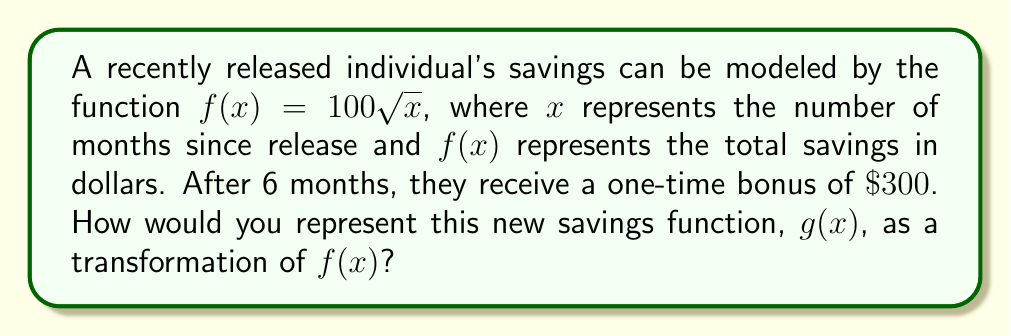What is the answer to this math problem? To solve this problem, we need to consider how the original function $f(x)$ is affected by the bonus:

1. The original function $f(x) = 100\sqrt{x}$ represents the savings growth over time.

2. The $300 bonus is received after 6 months, which means:
   - For $x < 6$, the function remains unchanged.
   - For $x \geq 6$, we need to add $300 to the original function.

3. This scenario represents a vertical shift of the function, but only for $x \geq 6$.

4. To represent this mathematically, we can use a piecewise function:

   $$g(x) = \begin{cases}
   f(x) & \text{if } x < 6 \\
   f(x) + 300 & \text{if } x \geq 6
   \end{cases}$$

5. Substituting the original function, we get:

   $$g(x) = \begin{cases}
   100\sqrt{x} & \text{if } x < 6 \\
   100\sqrt{x} + 300 & \text{if } x \geq 6
   \end{cases}$$

This piecewise function $g(x)$ represents the transformation of $f(x)$ that accounts for the $300 bonus after 6 months.
Answer: $$g(x) = \begin{cases}
100\sqrt{x} & \text{if } x < 6 \\
100\sqrt{x} + 300 & \text{if } x \geq 6
\end{cases}$$ 